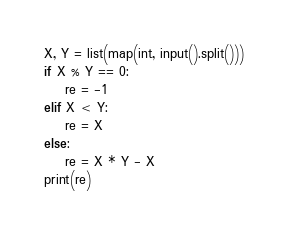<code> <loc_0><loc_0><loc_500><loc_500><_Python_>X, Y = list(map(int, input().split()))
if X % Y == 0:
    re = -1
elif X < Y:
    re = X
else:
    re = X * Y - X
print(re)</code> 